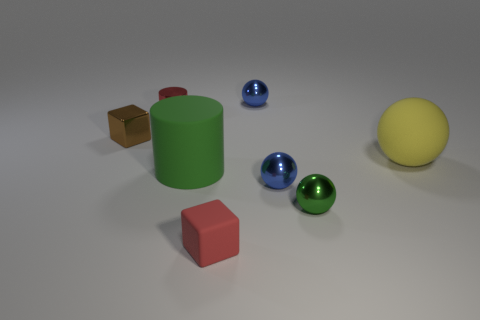Add 2 rubber objects. How many objects exist? 10 Subtract all cylinders. How many objects are left? 6 Add 5 cylinders. How many cylinders exist? 7 Subtract 0 yellow cylinders. How many objects are left? 8 Subtract all big things. Subtract all small cylinders. How many objects are left? 5 Add 2 tiny rubber objects. How many tiny rubber objects are left? 3 